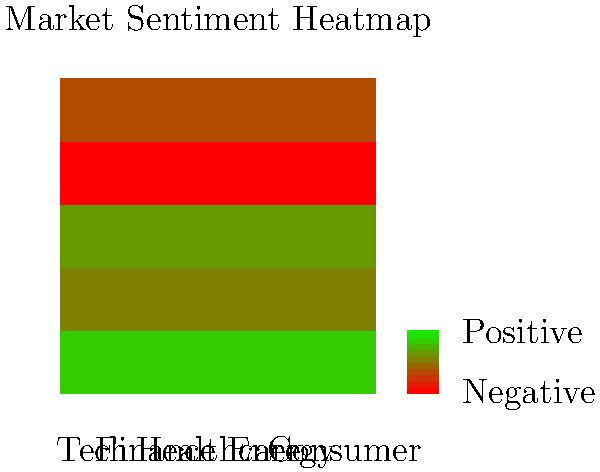Basándose en el mapa de calor del sentimiento del mercado por sectores, ¿qué sector muestra el sentimiento más positivo y cuál es la implicación más probable para las estrategias de inversión a corto plazo? Para responder a esta pregunta, sigamos estos pasos:

1. Interpretar el mapa de calor:
   - Los colores más verdes indican un sentimiento más positivo.
   - Los colores más rojos indican un sentimiento más negativo.

2. Analizar cada sector:
   - Tecnología (Tech): Verde más intenso, indica el sentimiento más positivo.
   - Finanzas (Finance): Verde moderado, sentimiento positivo pero menos que Tecnología.
   - Salud (Healthcare): Verde claro, sentimiento ligeramente positivo.
   - Energía (Energy): Rojo claro, sentimiento ligeramente negativo.
   - Consumo (Consumer): Verde muy claro, sentimiento neutral o ligeramente positivo.

3. Identificar el sector con el sentimiento más positivo:
   El sector Tecnología muestra el verde más intenso, indicando el sentimiento más positivo.

4. Implicaciones para estrategias de inversión a corto plazo:
   - Un sentimiento muy positivo en el sector tecnológico sugiere que los inversores están optimistas sobre su desempeño futuro.
   - Esto podría llevar a un aumento en la demanda de acciones tecnológicas a corto plazo.
   - Como resultado, es probable que veamos un incremento en los precios de las acciones tecnológicas en el corto plazo.

5. Estrategia de inversión probable:
   Considerando el fuerte sentimiento positivo, una estrategia de inversión a corto plazo podría ser sobreponderar el sector tecnológico en la cartera, aprovechando el momentum positivo del mercado.
Answer: Tecnología; sobreponderar el sector en la cartera a corto plazo. 